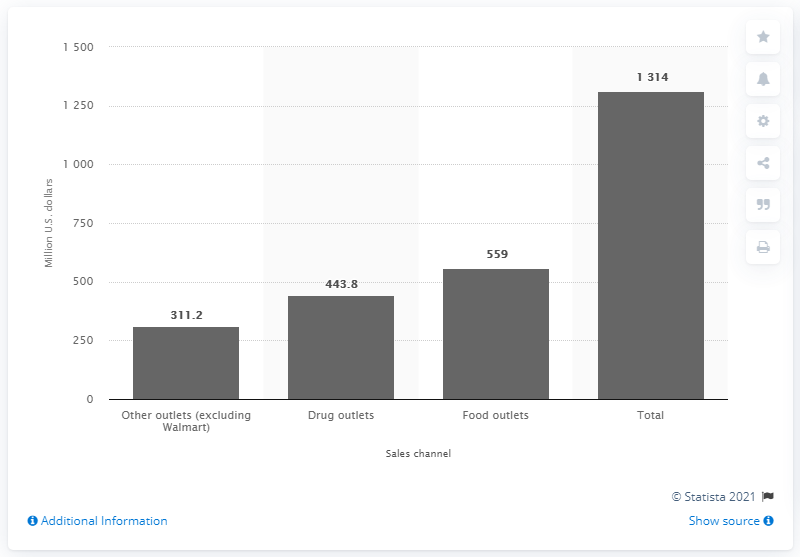List a handful of essential elements in this visual. In 2011/2012, a total of 559 U.S. dollars was spent on deodorant through food outlets. In 2011/2012, the total sales of deodorant in the United States were approximately 1314. 